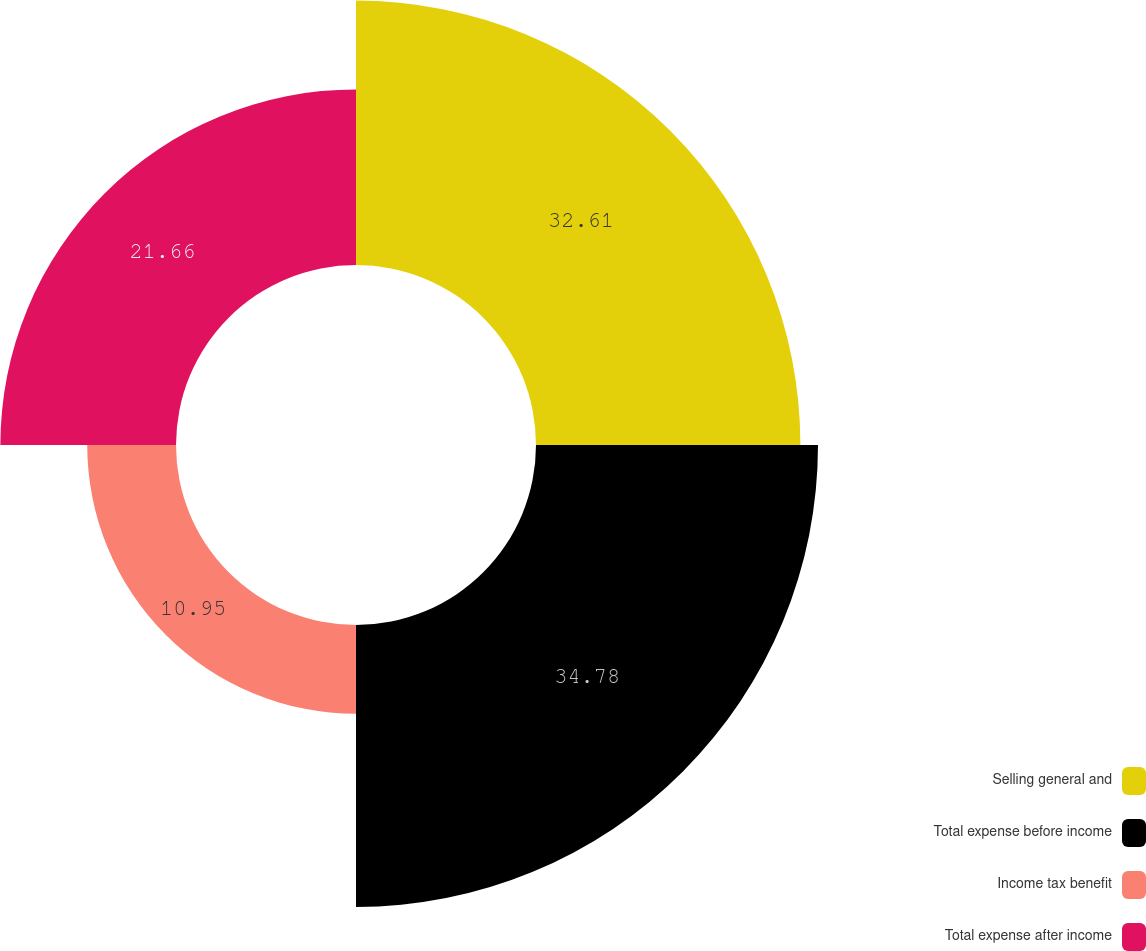<chart> <loc_0><loc_0><loc_500><loc_500><pie_chart><fcel>Selling general and<fcel>Total expense before income<fcel>Income tax benefit<fcel>Total expense after income<nl><fcel>32.61%<fcel>34.78%<fcel>10.95%<fcel>21.66%<nl></chart> 